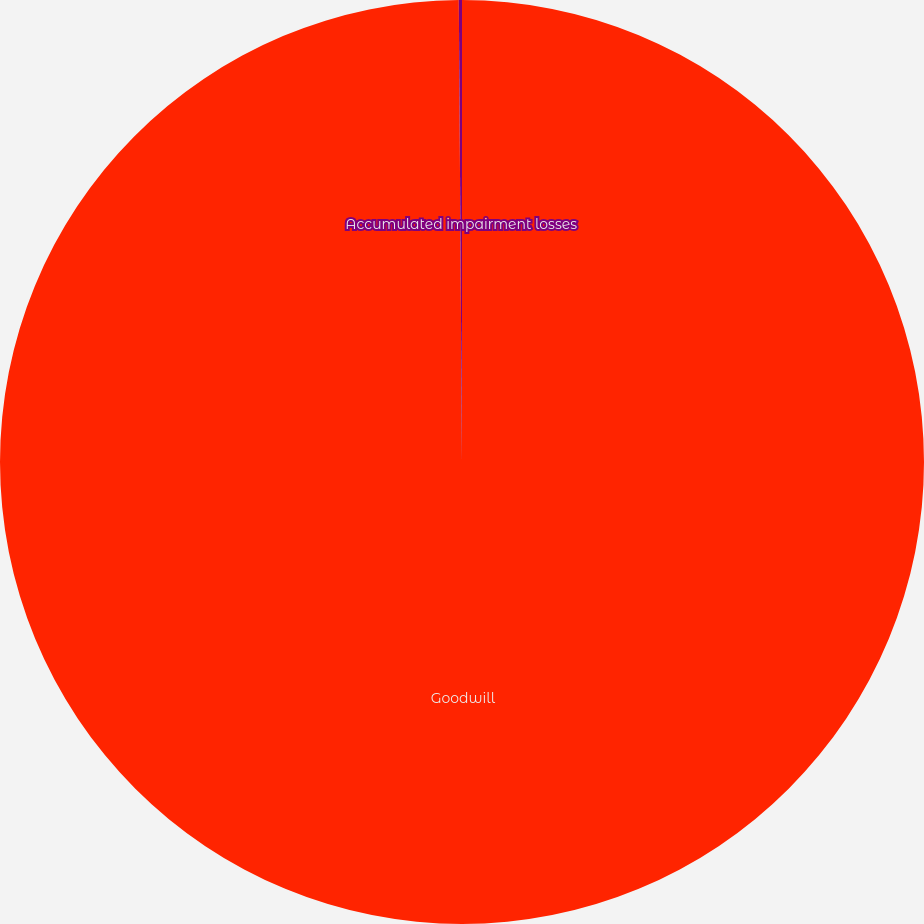Convert chart to OTSL. <chart><loc_0><loc_0><loc_500><loc_500><pie_chart><fcel>Goodwill<fcel>Accumulated impairment losses<nl><fcel>99.89%<fcel>0.11%<nl></chart> 